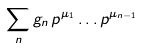<formula> <loc_0><loc_0><loc_500><loc_500>\sum _ { n } g _ { n } \, p ^ { \mu _ { 1 } } \dots p ^ { \mu _ { n - 1 } }</formula> 